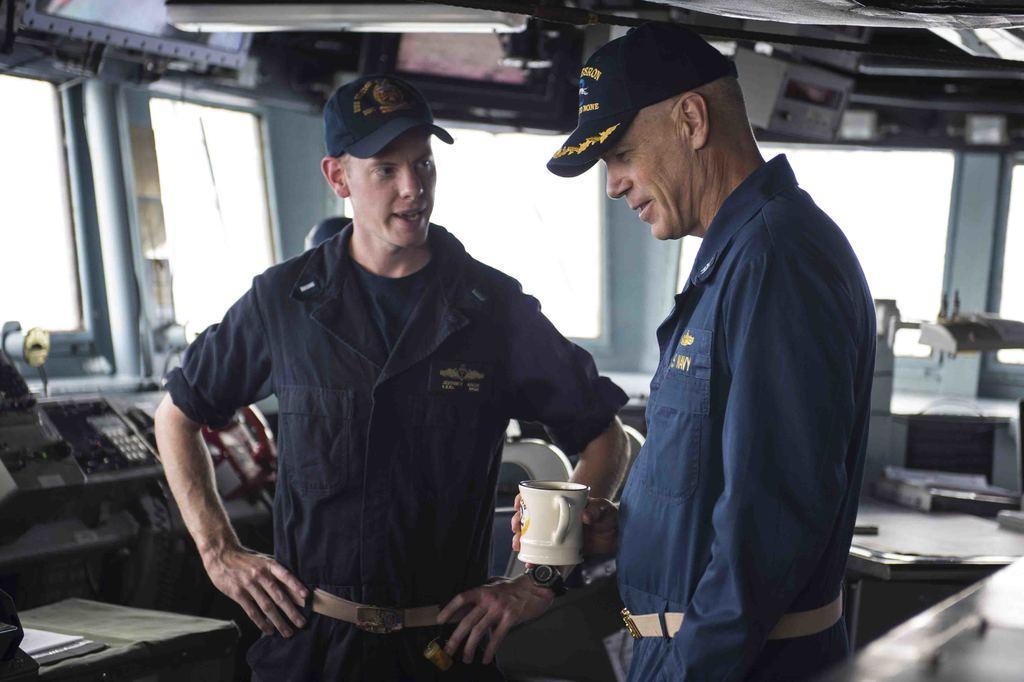Describe this image in one or two sentences. In this image in the foreground there are two persons who are standing and one person is holding a cup, it seems that they are talking. And in the background there is another person, and some tools and machines and some objects and also there are some windows. At the top there are some televisions and some other objects. 